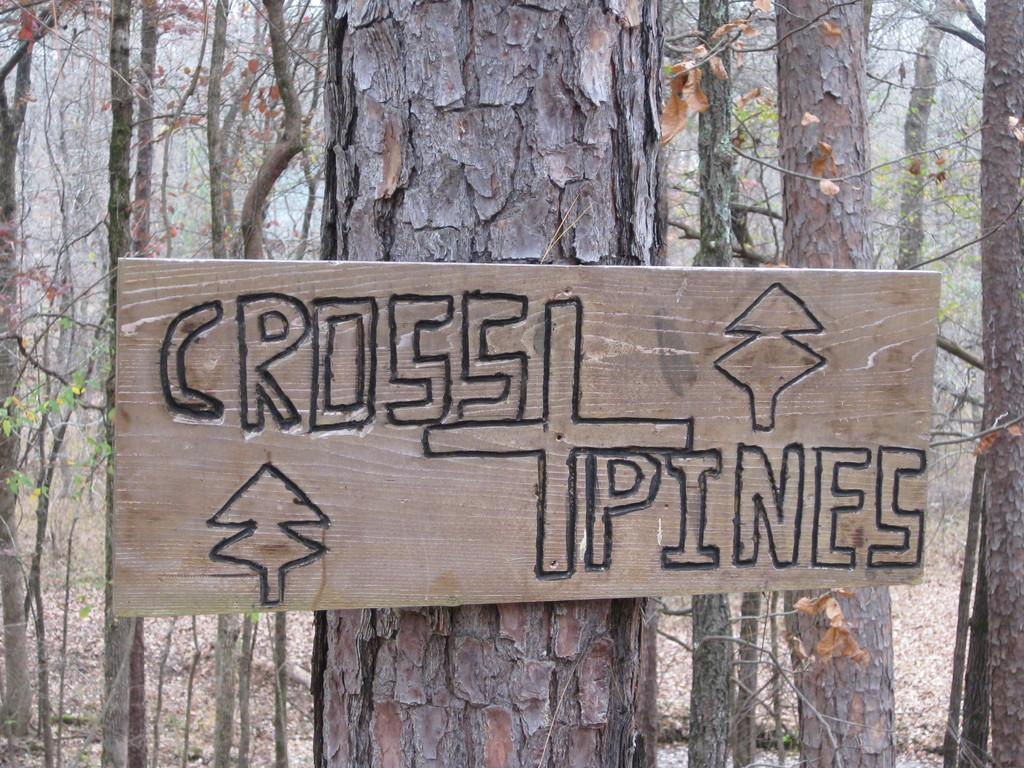What is the main subject in the foreground of the image? There is a tree trunk in the foreground of the image. Where is the tree trunk located in the image? The tree trunk is in the middle of the image. What else can be seen in the foreground of the image? There is a wooden board with text in the foreground of the image. What can be seen in the background of the image? There are trees visible in the background of the image. Can you tell me how many times the father jumps in the image? There is no father or jumping activity present in the image. 